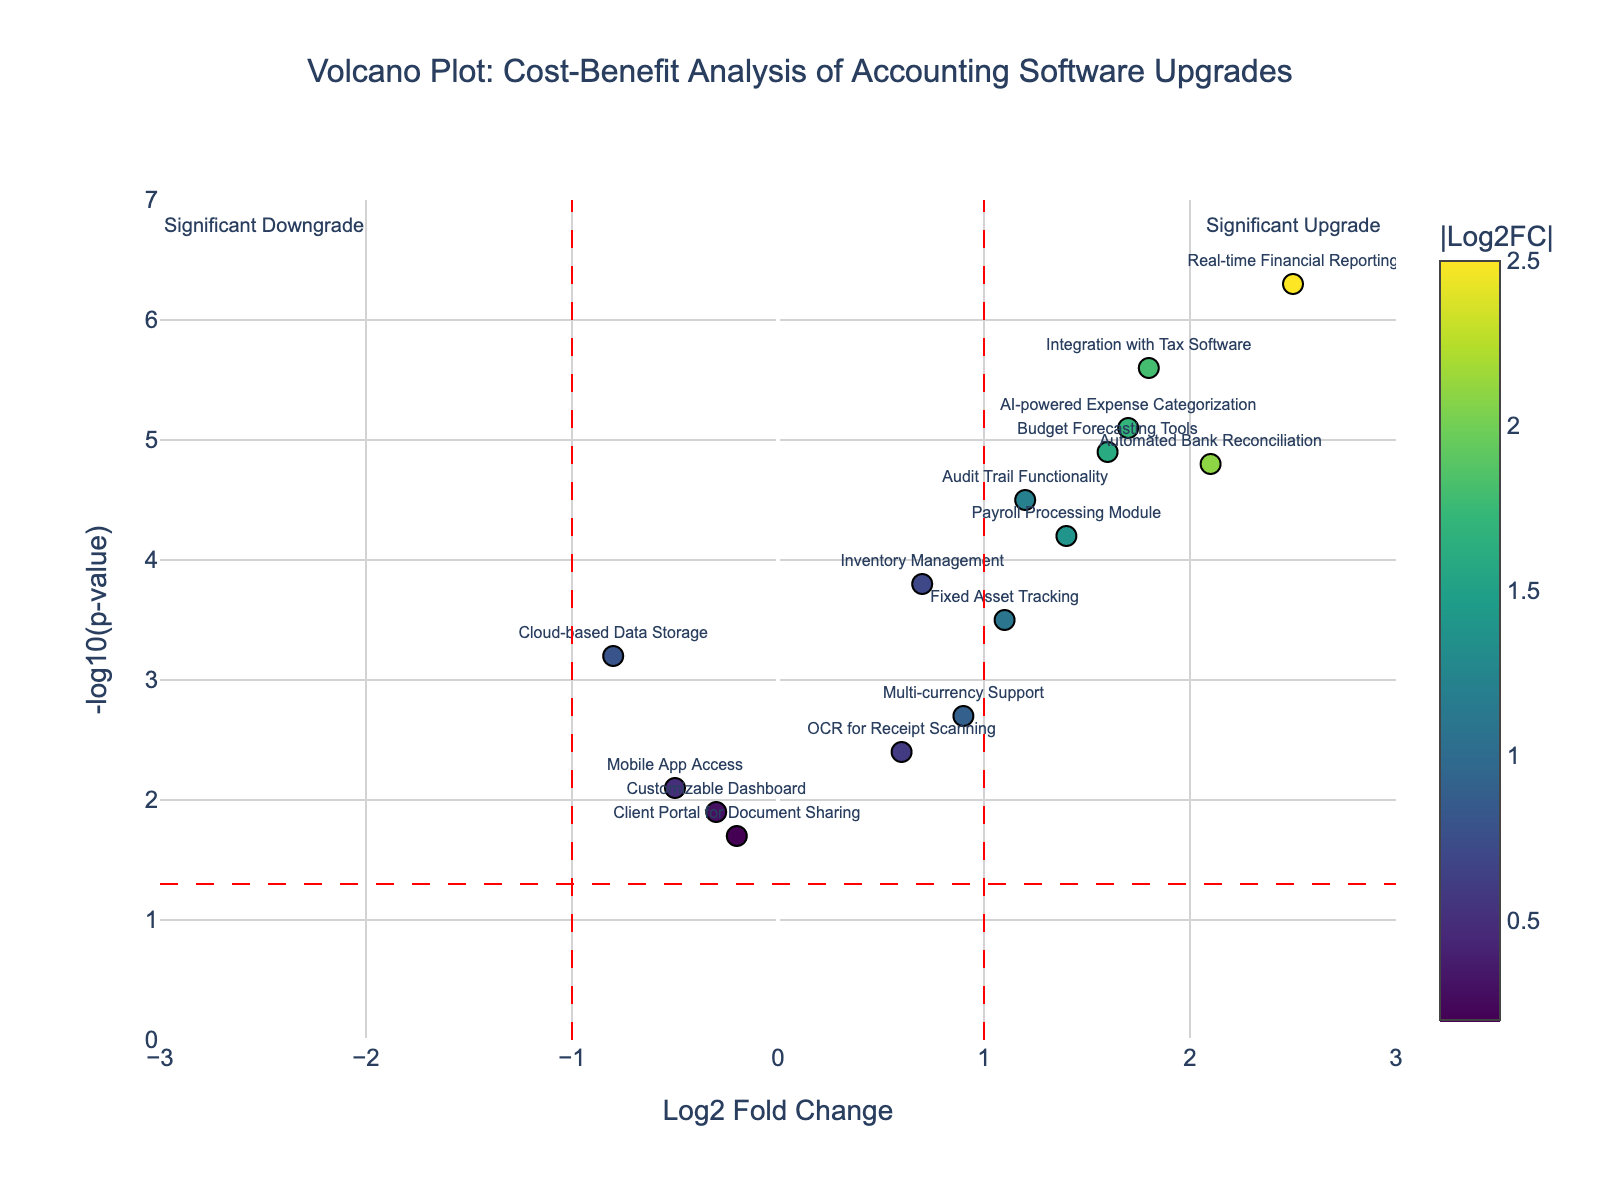How many features are displayed in the plot? To determine this, look at the number of data points or markers on the plot. Each marker represents a different feature.
Answer: 15 Which feature has the highest -log10(p-value)? By examining the y-axis, locate the highest position on the plot and refer to the feature labeled at that position.
Answer: Real-time Financial Reporting How many features have a Log2FoldChange greater than 1? Identify and count the data points that are positioned to the right of the vertical red dashed line at Log2FoldChange = 1.
Answer: 7 What is the range of the -log10(p-value) for the features? To determine the range, identify the minimum and maximum values on the y-axis, from the lowest to the highest data point. The minimum is near 1.7 and the maximum is near 6.3. The range is the difference between these values.
Answer: 4.6 Which feature provides the most cost-effective upgrade (highest benefit with lowest p-value)? This involves finding the feature with the highest Log2FoldChange on the right side of the plot while also having a high -log10(p-value). The ideal point is far right and high up, which is Real-time Financial Reporting.
Answer: Real-time Financial Reporting Are there any features considered significant downgrades? Check if there are any data points to the left of the vertical dashed line at Log2FoldChange = -1, with a -log10(p-value) above the horizontal dashed line. There are no data points in this area.
Answer: No Which features are close to the threshold for significant upgrades? Features close to the vertical red dashed line at Log2FoldChange = 1 but slightly less than this value are close to the threshold. Examples are AI-powered Expense Categorization and Audit Trail Functionality.
Answer: AI-powered Expense Categorization, Audit Trail Functionality What color indicates higher absolute Log2FoldChange values? Look at the color scale on the plot. Darker colors or higher values on the color bar indicate higher absolute values of Log2FoldChange.
Answer: Darker colors (closer to yellow) Which features have a -log10(p-value) less than 3? Locate the data points below the horizontal dashed line that represents -log10(0.05) ≈ 3. Examples are Cloud-based Data Storage, Multi-currency Support, Mobile App Access, OCR for Receipt Scanning, and Client Portal for Document Sharing.
Answer: Cloud-based Data Storage, Multi-currency Support, Mobile App Access, OCR for Receipt Scanning, Client Portal for Document Sharing 